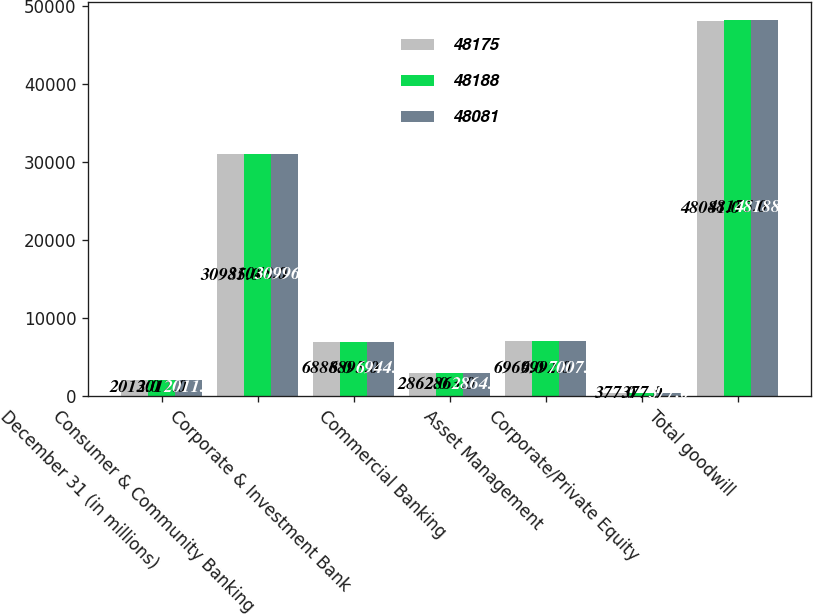Convert chart to OTSL. <chart><loc_0><loc_0><loc_500><loc_500><stacked_bar_chart><ecel><fcel>December 31 (in millions)<fcel>Consumer & Community Banking<fcel>Corporate & Investment Bank<fcel>Commercial Banking<fcel>Asset Management<fcel>Corporate/Private Equity<fcel>Total goodwill<nl><fcel>48175<fcel>2013<fcel>30985<fcel>6888<fcel>2862<fcel>6969<fcel>377<fcel>48081<nl><fcel>48188<fcel>2012<fcel>31048<fcel>6895<fcel>2863<fcel>6992<fcel>377<fcel>48175<nl><fcel>48081<fcel>2011<fcel>30996<fcel>6944<fcel>2864<fcel>7007<fcel>377<fcel>48188<nl></chart> 